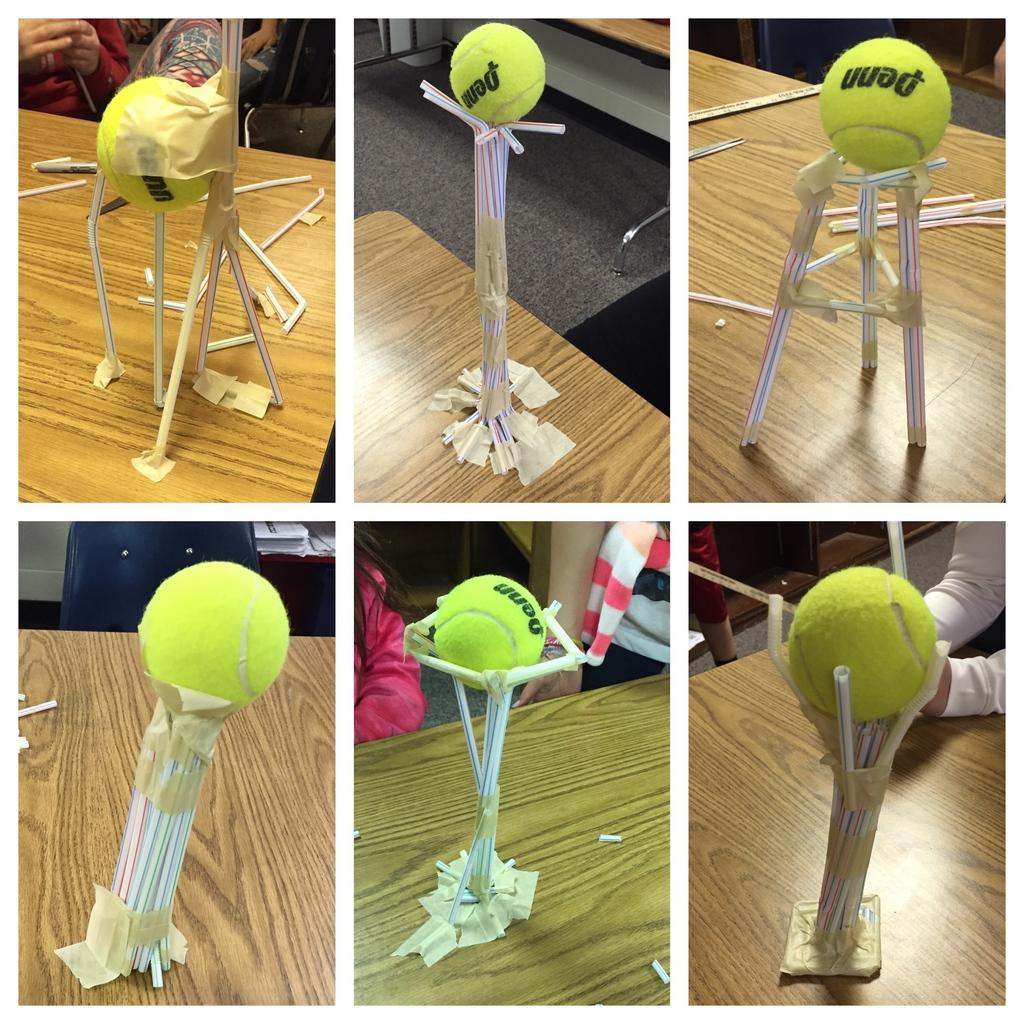What type of artwork is depicted in the image? The image is a collage. What can be seen on top of the objects in the collage? There are balls placed on objects in the image. What is the surface made of that the objects are placed on? The objects are on a wooden surface. Can you describe the people visible in the image? There are people visible in the image, but their specific features or actions are not mentioned in the provided facts. What is visible below the wooden surface in the image? The ground is visible in the image. How many tickets are being held by the mice in the image? There are no mice or tickets present in the image. What type of place is shown in the image? The provided facts do not mention any specific place or setting; the image is a collage with balls placed on objects on a wooden surface. 